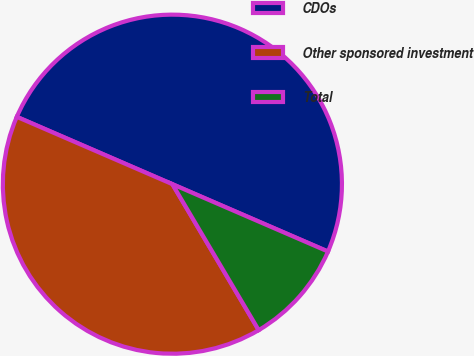<chart> <loc_0><loc_0><loc_500><loc_500><pie_chart><fcel>CDOs<fcel>Other sponsored investment<fcel>Total<nl><fcel>50.0%<fcel>40.0%<fcel>10.0%<nl></chart> 